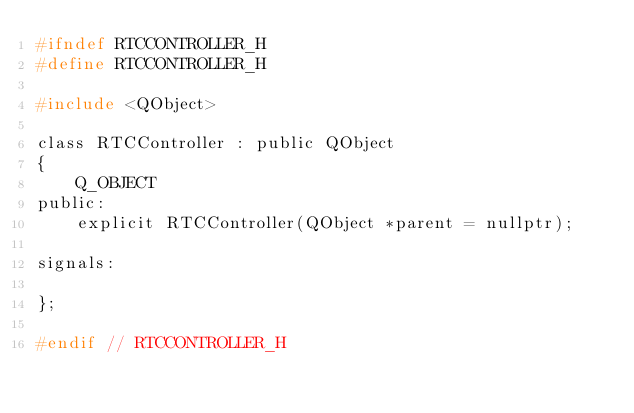Convert code to text. <code><loc_0><loc_0><loc_500><loc_500><_C_>#ifndef RTCCONTROLLER_H
#define RTCCONTROLLER_H

#include <QObject>

class RTCController : public QObject
{
    Q_OBJECT
public:
    explicit RTCController(QObject *parent = nullptr);

signals:

};

#endif // RTCCONTROLLER_H
</code> 